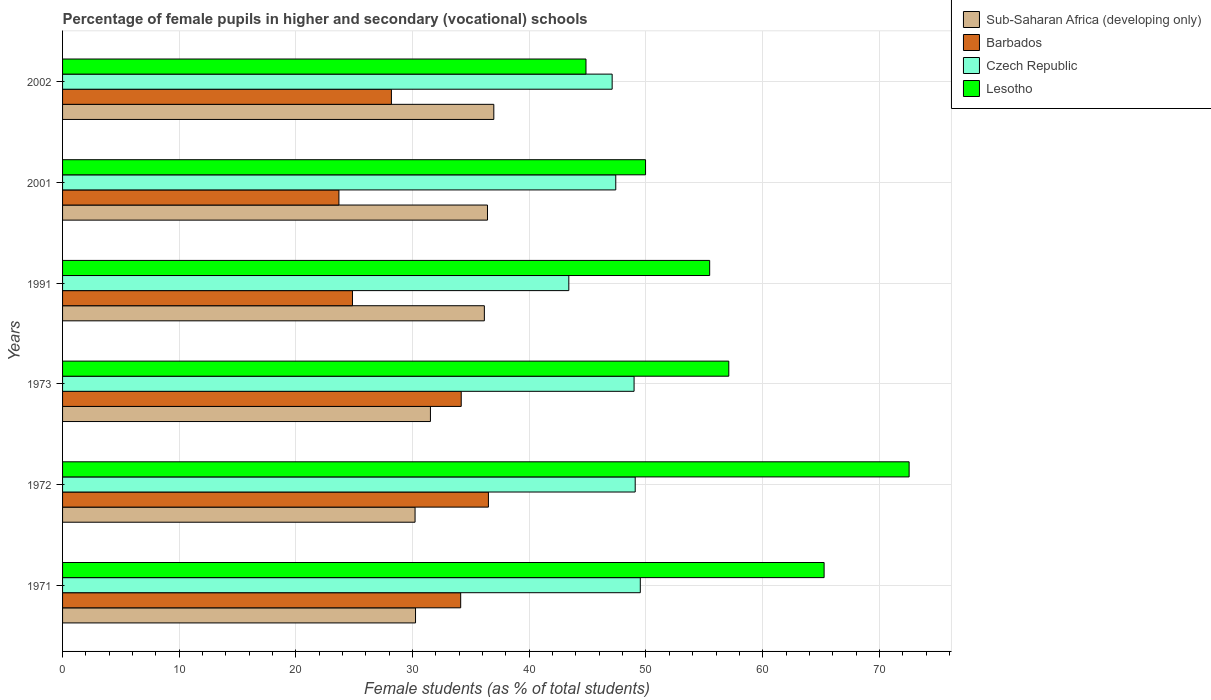How many different coloured bars are there?
Your answer should be very brief. 4. How many groups of bars are there?
Make the answer very short. 6. How many bars are there on the 2nd tick from the top?
Keep it short and to the point. 4. How many bars are there on the 6th tick from the bottom?
Ensure brevity in your answer.  4. What is the label of the 2nd group of bars from the top?
Your response must be concise. 2001. In how many cases, is the number of bars for a given year not equal to the number of legend labels?
Make the answer very short. 0. What is the percentage of female pupils in higher and secondary schools in Czech Republic in 2001?
Your answer should be compact. 47.41. Across all years, what is the maximum percentage of female pupils in higher and secondary schools in Czech Republic?
Your response must be concise. 49.51. Across all years, what is the minimum percentage of female pupils in higher and secondary schools in Czech Republic?
Make the answer very short. 43.39. In which year was the percentage of female pupils in higher and secondary schools in Sub-Saharan Africa (developing only) maximum?
Offer a terse response. 2002. In which year was the percentage of female pupils in higher and secondary schools in Sub-Saharan Africa (developing only) minimum?
Keep it short and to the point. 1972. What is the total percentage of female pupils in higher and secondary schools in Czech Republic in the graph?
Provide a succinct answer. 285.46. What is the difference between the percentage of female pupils in higher and secondary schools in Lesotho in 1991 and that in 2002?
Offer a terse response. 10.6. What is the difference between the percentage of female pupils in higher and secondary schools in Czech Republic in 2001 and the percentage of female pupils in higher and secondary schools in Lesotho in 2002?
Give a very brief answer. 2.55. What is the average percentage of female pupils in higher and secondary schools in Lesotho per year?
Provide a short and direct response. 57.53. In the year 2002, what is the difference between the percentage of female pupils in higher and secondary schools in Barbados and percentage of female pupils in higher and secondary schools in Czech Republic?
Make the answer very short. -18.92. What is the ratio of the percentage of female pupils in higher and secondary schools in Sub-Saharan Africa (developing only) in 1971 to that in 2001?
Provide a short and direct response. 0.83. Is the difference between the percentage of female pupils in higher and secondary schools in Barbados in 1973 and 2002 greater than the difference between the percentage of female pupils in higher and secondary schools in Czech Republic in 1973 and 2002?
Offer a very short reply. Yes. What is the difference between the highest and the second highest percentage of female pupils in higher and secondary schools in Czech Republic?
Give a very brief answer. 0.44. What is the difference between the highest and the lowest percentage of female pupils in higher and secondary schools in Lesotho?
Keep it short and to the point. 27.69. In how many years, is the percentage of female pupils in higher and secondary schools in Lesotho greater than the average percentage of female pupils in higher and secondary schools in Lesotho taken over all years?
Your answer should be very brief. 2. What does the 1st bar from the top in 1972 represents?
Your response must be concise. Lesotho. What does the 3rd bar from the bottom in 1972 represents?
Provide a short and direct response. Czech Republic. How many bars are there?
Provide a succinct answer. 24. What is the title of the graph?
Keep it short and to the point. Percentage of female pupils in higher and secondary (vocational) schools. Does "Andorra" appear as one of the legend labels in the graph?
Make the answer very short. No. What is the label or title of the X-axis?
Keep it short and to the point. Female students (as % of total students). What is the Female students (as % of total students) of Sub-Saharan Africa (developing only) in 1971?
Your answer should be compact. 30.25. What is the Female students (as % of total students) of Barbados in 1971?
Provide a succinct answer. 34.12. What is the Female students (as % of total students) of Czech Republic in 1971?
Your answer should be very brief. 49.51. What is the Female students (as % of total students) of Lesotho in 1971?
Make the answer very short. 65.27. What is the Female students (as % of total students) of Sub-Saharan Africa (developing only) in 1972?
Provide a short and direct response. 30.21. What is the Female students (as % of total students) of Barbados in 1972?
Keep it short and to the point. 36.5. What is the Female students (as % of total students) of Czech Republic in 1972?
Give a very brief answer. 49.08. What is the Female students (as % of total students) of Lesotho in 1972?
Keep it short and to the point. 72.55. What is the Female students (as % of total students) of Sub-Saharan Africa (developing only) in 1973?
Keep it short and to the point. 31.53. What is the Female students (as % of total students) in Barbados in 1973?
Offer a very short reply. 34.17. What is the Female students (as % of total students) of Czech Republic in 1973?
Keep it short and to the point. 48.98. What is the Female students (as % of total students) of Lesotho in 1973?
Provide a succinct answer. 57.1. What is the Female students (as % of total students) of Sub-Saharan Africa (developing only) in 1991?
Your response must be concise. 36.15. What is the Female students (as % of total students) in Barbados in 1991?
Offer a terse response. 24.84. What is the Female students (as % of total students) in Czech Republic in 1991?
Give a very brief answer. 43.39. What is the Female students (as % of total students) in Lesotho in 1991?
Provide a short and direct response. 55.46. What is the Female students (as % of total students) in Sub-Saharan Africa (developing only) in 2001?
Offer a terse response. 36.42. What is the Female students (as % of total students) of Barbados in 2001?
Offer a very short reply. 23.68. What is the Female students (as % of total students) in Czech Republic in 2001?
Give a very brief answer. 47.41. What is the Female students (as % of total students) in Lesotho in 2001?
Keep it short and to the point. 49.96. What is the Female students (as % of total students) in Sub-Saharan Africa (developing only) in 2002?
Ensure brevity in your answer.  36.96. What is the Female students (as % of total students) of Barbados in 2002?
Keep it short and to the point. 28.18. What is the Female students (as % of total students) in Czech Republic in 2002?
Keep it short and to the point. 47.1. What is the Female students (as % of total students) in Lesotho in 2002?
Make the answer very short. 44.86. Across all years, what is the maximum Female students (as % of total students) of Sub-Saharan Africa (developing only)?
Keep it short and to the point. 36.96. Across all years, what is the maximum Female students (as % of total students) of Barbados?
Your response must be concise. 36.5. Across all years, what is the maximum Female students (as % of total students) in Czech Republic?
Your answer should be compact. 49.51. Across all years, what is the maximum Female students (as % of total students) in Lesotho?
Provide a succinct answer. 72.55. Across all years, what is the minimum Female students (as % of total students) of Sub-Saharan Africa (developing only)?
Make the answer very short. 30.21. Across all years, what is the minimum Female students (as % of total students) of Barbados?
Your answer should be compact. 23.68. Across all years, what is the minimum Female students (as % of total students) of Czech Republic?
Your response must be concise. 43.39. Across all years, what is the minimum Female students (as % of total students) of Lesotho?
Offer a very short reply. 44.86. What is the total Female students (as % of total students) of Sub-Saharan Africa (developing only) in the graph?
Make the answer very short. 201.51. What is the total Female students (as % of total students) in Barbados in the graph?
Your response must be concise. 181.49. What is the total Female students (as % of total students) of Czech Republic in the graph?
Your answer should be compact. 285.46. What is the total Female students (as % of total students) in Lesotho in the graph?
Offer a very short reply. 345.19. What is the difference between the Female students (as % of total students) in Sub-Saharan Africa (developing only) in 1971 and that in 1972?
Your answer should be compact. 0.04. What is the difference between the Female students (as % of total students) of Barbados in 1971 and that in 1972?
Your response must be concise. -2.38. What is the difference between the Female students (as % of total students) of Czech Republic in 1971 and that in 1972?
Provide a succinct answer. 0.44. What is the difference between the Female students (as % of total students) of Lesotho in 1971 and that in 1972?
Provide a short and direct response. -7.29. What is the difference between the Female students (as % of total students) in Sub-Saharan Africa (developing only) in 1971 and that in 1973?
Give a very brief answer. -1.28. What is the difference between the Female students (as % of total students) in Barbados in 1971 and that in 1973?
Give a very brief answer. -0.05. What is the difference between the Female students (as % of total students) in Czech Republic in 1971 and that in 1973?
Your answer should be compact. 0.53. What is the difference between the Female students (as % of total students) in Lesotho in 1971 and that in 1973?
Make the answer very short. 8.17. What is the difference between the Female students (as % of total students) in Sub-Saharan Africa (developing only) in 1971 and that in 1991?
Keep it short and to the point. -5.9. What is the difference between the Female students (as % of total students) in Barbados in 1971 and that in 1991?
Offer a terse response. 9.27. What is the difference between the Female students (as % of total students) in Czech Republic in 1971 and that in 1991?
Offer a very short reply. 6.13. What is the difference between the Female students (as % of total students) of Lesotho in 1971 and that in 1991?
Offer a terse response. 9.81. What is the difference between the Female students (as % of total students) in Sub-Saharan Africa (developing only) in 1971 and that in 2001?
Your answer should be compact. -6.17. What is the difference between the Female students (as % of total students) in Barbados in 1971 and that in 2001?
Give a very brief answer. 10.43. What is the difference between the Female students (as % of total students) in Czech Republic in 1971 and that in 2001?
Your answer should be very brief. 2.1. What is the difference between the Female students (as % of total students) of Lesotho in 1971 and that in 2001?
Offer a terse response. 15.3. What is the difference between the Female students (as % of total students) of Sub-Saharan Africa (developing only) in 1971 and that in 2002?
Make the answer very short. -6.71. What is the difference between the Female students (as % of total students) of Barbados in 1971 and that in 2002?
Your answer should be very brief. 5.94. What is the difference between the Female students (as % of total students) in Czech Republic in 1971 and that in 2002?
Your response must be concise. 2.41. What is the difference between the Female students (as % of total students) in Lesotho in 1971 and that in 2002?
Give a very brief answer. 20.41. What is the difference between the Female students (as % of total students) of Sub-Saharan Africa (developing only) in 1972 and that in 1973?
Your answer should be very brief. -1.32. What is the difference between the Female students (as % of total students) of Barbados in 1972 and that in 1973?
Offer a very short reply. 2.33. What is the difference between the Female students (as % of total students) in Czech Republic in 1972 and that in 1973?
Give a very brief answer. 0.1. What is the difference between the Female students (as % of total students) in Lesotho in 1972 and that in 1973?
Make the answer very short. 15.45. What is the difference between the Female students (as % of total students) of Sub-Saharan Africa (developing only) in 1972 and that in 1991?
Your answer should be compact. -5.94. What is the difference between the Female students (as % of total students) of Barbados in 1972 and that in 1991?
Ensure brevity in your answer.  11.65. What is the difference between the Female students (as % of total students) in Czech Republic in 1972 and that in 1991?
Provide a short and direct response. 5.69. What is the difference between the Female students (as % of total students) of Lesotho in 1972 and that in 1991?
Keep it short and to the point. 17.09. What is the difference between the Female students (as % of total students) in Sub-Saharan Africa (developing only) in 1972 and that in 2001?
Your answer should be very brief. -6.21. What is the difference between the Female students (as % of total students) of Barbados in 1972 and that in 2001?
Your response must be concise. 12.81. What is the difference between the Female students (as % of total students) of Czech Republic in 1972 and that in 2001?
Offer a terse response. 1.67. What is the difference between the Female students (as % of total students) in Lesotho in 1972 and that in 2001?
Ensure brevity in your answer.  22.59. What is the difference between the Female students (as % of total students) in Sub-Saharan Africa (developing only) in 1972 and that in 2002?
Offer a very short reply. -6.75. What is the difference between the Female students (as % of total students) in Barbados in 1972 and that in 2002?
Offer a very short reply. 8.31. What is the difference between the Female students (as % of total students) of Czech Republic in 1972 and that in 2002?
Make the answer very short. 1.98. What is the difference between the Female students (as % of total students) in Lesotho in 1972 and that in 2002?
Offer a terse response. 27.69. What is the difference between the Female students (as % of total students) in Sub-Saharan Africa (developing only) in 1973 and that in 1991?
Provide a short and direct response. -4.62. What is the difference between the Female students (as % of total students) of Barbados in 1973 and that in 1991?
Offer a terse response. 9.32. What is the difference between the Female students (as % of total students) of Czech Republic in 1973 and that in 1991?
Give a very brief answer. 5.59. What is the difference between the Female students (as % of total students) of Lesotho in 1973 and that in 1991?
Keep it short and to the point. 1.64. What is the difference between the Female students (as % of total students) in Sub-Saharan Africa (developing only) in 1973 and that in 2001?
Your response must be concise. -4.89. What is the difference between the Female students (as % of total students) in Barbados in 1973 and that in 2001?
Offer a terse response. 10.48. What is the difference between the Female students (as % of total students) of Czech Republic in 1973 and that in 2001?
Provide a succinct answer. 1.57. What is the difference between the Female students (as % of total students) in Lesotho in 1973 and that in 2001?
Give a very brief answer. 7.13. What is the difference between the Female students (as % of total students) of Sub-Saharan Africa (developing only) in 1973 and that in 2002?
Your response must be concise. -5.43. What is the difference between the Female students (as % of total students) in Barbados in 1973 and that in 2002?
Your answer should be compact. 5.98. What is the difference between the Female students (as % of total students) of Czech Republic in 1973 and that in 2002?
Offer a very short reply. 1.88. What is the difference between the Female students (as % of total students) of Lesotho in 1973 and that in 2002?
Your answer should be compact. 12.24. What is the difference between the Female students (as % of total students) of Sub-Saharan Africa (developing only) in 1991 and that in 2001?
Make the answer very short. -0.27. What is the difference between the Female students (as % of total students) in Barbados in 1991 and that in 2001?
Your response must be concise. 1.16. What is the difference between the Female students (as % of total students) in Czech Republic in 1991 and that in 2001?
Ensure brevity in your answer.  -4.02. What is the difference between the Female students (as % of total students) of Lesotho in 1991 and that in 2001?
Make the answer very short. 5.5. What is the difference between the Female students (as % of total students) in Sub-Saharan Africa (developing only) in 1991 and that in 2002?
Your answer should be very brief. -0.81. What is the difference between the Female students (as % of total students) in Barbados in 1991 and that in 2002?
Give a very brief answer. -3.34. What is the difference between the Female students (as % of total students) of Czech Republic in 1991 and that in 2002?
Your answer should be very brief. -3.71. What is the difference between the Female students (as % of total students) of Lesotho in 1991 and that in 2002?
Make the answer very short. 10.6. What is the difference between the Female students (as % of total students) in Sub-Saharan Africa (developing only) in 2001 and that in 2002?
Ensure brevity in your answer.  -0.54. What is the difference between the Female students (as % of total students) of Barbados in 2001 and that in 2002?
Offer a very short reply. -4.5. What is the difference between the Female students (as % of total students) of Czech Republic in 2001 and that in 2002?
Keep it short and to the point. 0.31. What is the difference between the Female students (as % of total students) in Lesotho in 2001 and that in 2002?
Keep it short and to the point. 5.1. What is the difference between the Female students (as % of total students) of Sub-Saharan Africa (developing only) in 1971 and the Female students (as % of total students) of Barbados in 1972?
Make the answer very short. -6.25. What is the difference between the Female students (as % of total students) of Sub-Saharan Africa (developing only) in 1971 and the Female students (as % of total students) of Czech Republic in 1972?
Provide a succinct answer. -18.83. What is the difference between the Female students (as % of total students) of Sub-Saharan Africa (developing only) in 1971 and the Female students (as % of total students) of Lesotho in 1972?
Ensure brevity in your answer.  -42.3. What is the difference between the Female students (as % of total students) of Barbados in 1971 and the Female students (as % of total students) of Czech Republic in 1972?
Provide a short and direct response. -14.96. What is the difference between the Female students (as % of total students) of Barbados in 1971 and the Female students (as % of total students) of Lesotho in 1972?
Keep it short and to the point. -38.43. What is the difference between the Female students (as % of total students) of Czech Republic in 1971 and the Female students (as % of total students) of Lesotho in 1972?
Give a very brief answer. -23.04. What is the difference between the Female students (as % of total students) of Sub-Saharan Africa (developing only) in 1971 and the Female students (as % of total students) of Barbados in 1973?
Your answer should be very brief. -3.92. What is the difference between the Female students (as % of total students) in Sub-Saharan Africa (developing only) in 1971 and the Female students (as % of total students) in Czech Republic in 1973?
Provide a succinct answer. -18.73. What is the difference between the Female students (as % of total students) in Sub-Saharan Africa (developing only) in 1971 and the Female students (as % of total students) in Lesotho in 1973?
Give a very brief answer. -26.85. What is the difference between the Female students (as % of total students) of Barbados in 1971 and the Female students (as % of total students) of Czech Republic in 1973?
Your answer should be compact. -14.86. What is the difference between the Female students (as % of total students) of Barbados in 1971 and the Female students (as % of total students) of Lesotho in 1973?
Offer a very short reply. -22.98. What is the difference between the Female students (as % of total students) in Czech Republic in 1971 and the Female students (as % of total students) in Lesotho in 1973?
Offer a terse response. -7.58. What is the difference between the Female students (as % of total students) of Sub-Saharan Africa (developing only) in 1971 and the Female students (as % of total students) of Barbados in 1991?
Offer a very short reply. 5.4. What is the difference between the Female students (as % of total students) in Sub-Saharan Africa (developing only) in 1971 and the Female students (as % of total students) in Czech Republic in 1991?
Give a very brief answer. -13.14. What is the difference between the Female students (as % of total students) of Sub-Saharan Africa (developing only) in 1971 and the Female students (as % of total students) of Lesotho in 1991?
Offer a terse response. -25.21. What is the difference between the Female students (as % of total students) of Barbados in 1971 and the Female students (as % of total students) of Czech Republic in 1991?
Provide a short and direct response. -9.27. What is the difference between the Female students (as % of total students) in Barbados in 1971 and the Female students (as % of total students) in Lesotho in 1991?
Provide a short and direct response. -21.34. What is the difference between the Female students (as % of total students) in Czech Republic in 1971 and the Female students (as % of total students) in Lesotho in 1991?
Provide a short and direct response. -5.95. What is the difference between the Female students (as % of total students) of Sub-Saharan Africa (developing only) in 1971 and the Female students (as % of total students) of Barbados in 2001?
Provide a succinct answer. 6.57. What is the difference between the Female students (as % of total students) in Sub-Saharan Africa (developing only) in 1971 and the Female students (as % of total students) in Czech Republic in 2001?
Your answer should be very brief. -17.16. What is the difference between the Female students (as % of total students) in Sub-Saharan Africa (developing only) in 1971 and the Female students (as % of total students) in Lesotho in 2001?
Keep it short and to the point. -19.71. What is the difference between the Female students (as % of total students) of Barbados in 1971 and the Female students (as % of total students) of Czech Republic in 2001?
Your answer should be compact. -13.29. What is the difference between the Female students (as % of total students) of Barbados in 1971 and the Female students (as % of total students) of Lesotho in 2001?
Make the answer very short. -15.84. What is the difference between the Female students (as % of total students) of Czech Republic in 1971 and the Female students (as % of total students) of Lesotho in 2001?
Provide a succinct answer. -0.45. What is the difference between the Female students (as % of total students) in Sub-Saharan Africa (developing only) in 1971 and the Female students (as % of total students) in Barbados in 2002?
Provide a short and direct response. 2.07. What is the difference between the Female students (as % of total students) in Sub-Saharan Africa (developing only) in 1971 and the Female students (as % of total students) in Czech Republic in 2002?
Offer a very short reply. -16.85. What is the difference between the Female students (as % of total students) in Sub-Saharan Africa (developing only) in 1971 and the Female students (as % of total students) in Lesotho in 2002?
Offer a very short reply. -14.61. What is the difference between the Female students (as % of total students) of Barbados in 1971 and the Female students (as % of total students) of Czech Republic in 2002?
Offer a terse response. -12.98. What is the difference between the Female students (as % of total students) in Barbados in 1971 and the Female students (as % of total students) in Lesotho in 2002?
Give a very brief answer. -10.74. What is the difference between the Female students (as % of total students) of Czech Republic in 1971 and the Female students (as % of total students) of Lesotho in 2002?
Offer a very short reply. 4.65. What is the difference between the Female students (as % of total students) of Sub-Saharan Africa (developing only) in 1972 and the Female students (as % of total students) of Barbados in 1973?
Provide a succinct answer. -3.96. What is the difference between the Female students (as % of total students) in Sub-Saharan Africa (developing only) in 1972 and the Female students (as % of total students) in Czech Republic in 1973?
Your answer should be very brief. -18.77. What is the difference between the Female students (as % of total students) of Sub-Saharan Africa (developing only) in 1972 and the Female students (as % of total students) of Lesotho in 1973?
Your response must be concise. -26.89. What is the difference between the Female students (as % of total students) in Barbados in 1972 and the Female students (as % of total students) in Czech Republic in 1973?
Your answer should be compact. -12.48. What is the difference between the Female students (as % of total students) of Barbados in 1972 and the Female students (as % of total students) of Lesotho in 1973?
Offer a very short reply. -20.6. What is the difference between the Female students (as % of total students) of Czech Republic in 1972 and the Female students (as % of total students) of Lesotho in 1973?
Offer a terse response. -8.02. What is the difference between the Female students (as % of total students) in Sub-Saharan Africa (developing only) in 1972 and the Female students (as % of total students) in Barbados in 1991?
Make the answer very short. 5.36. What is the difference between the Female students (as % of total students) of Sub-Saharan Africa (developing only) in 1972 and the Female students (as % of total students) of Czech Republic in 1991?
Offer a very short reply. -13.18. What is the difference between the Female students (as % of total students) in Sub-Saharan Africa (developing only) in 1972 and the Female students (as % of total students) in Lesotho in 1991?
Provide a short and direct response. -25.25. What is the difference between the Female students (as % of total students) of Barbados in 1972 and the Female students (as % of total students) of Czech Republic in 1991?
Keep it short and to the point. -6.89. What is the difference between the Female students (as % of total students) of Barbados in 1972 and the Female students (as % of total students) of Lesotho in 1991?
Give a very brief answer. -18.96. What is the difference between the Female students (as % of total students) of Czech Republic in 1972 and the Female students (as % of total students) of Lesotho in 1991?
Give a very brief answer. -6.38. What is the difference between the Female students (as % of total students) of Sub-Saharan Africa (developing only) in 1972 and the Female students (as % of total students) of Barbados in 2001?
Make the answer very short. 6.52. What is the difference between the Female students (as % of total students) in Sub-Saharan Africa (developing only) in 1972 and the Female students (as % of total students) in Czech Republic in 2001?
Ensure brevity in your answer.  -17.2. What is the difference between the Female students (as % of total students) in Sub-Saharan Africa (developing only) in 1972 and the Female students (as % of total students) in Lesotho in 2001?
Offer a terse response. -19.75. What is the difference between the Female students (as % of total students) in Barbados in 1972 and the Female students (as % of total students) in Czech Republic in 2001?
Offer a terse response. -10.91. What is the difference between the Female students (as % of total students) in Barbados in 1972 and the Female students (as % of total students) in Lesotho in 2001?
Ensure brevity in your answer.  -13.47. What is the difference between the Female students (as % of total students) of Czech Republic in 1972 and the Female students (as % of total students) of Lesotho in 2001?
Offer a terse response. -0.89. What is the difference between the Female students (as % of total students) of Sub-Saharan Africa (developing only) in 1972 and the Female students (as % of total students) of Barbados in 2002?
Your answer should be very brief. 2.03. What is the difference between the Female students (as % of total students) of Sub-Saharan Africa (developing only) in 1972 and the Female students (as % of total students) of Czech Republic in 2002?
Make the answer very short. -16.89. What is the difference between the Female students (as % of total students) in Sub-Saharan Africa (developing only) in 1972 and the Female students (as % of total students) in Lesotho in 2002?
Your answer should be compact. -14.65. What is the difference between the Female students (as % of total students) in Barbados in 1972 and the Female students (as % of total students) in Czech Republic in 2002?
Offer a terse response. -10.6. What is the difference between the Female students (as % of total students) of Barbados in 1972 and the Female students (as % of total students) of Lesotho in 2002?
Keep it short and to the point. -8.36. What is the difference between the Female students (as % of total students) of Czech Republic in 1972 and the Female students (as % of total students) of Lesotho in 2002?
Provide a succinct answer. 4.22. What is the difference between the Female students (as % of total students) of Sub-Saharan Africa (developing only) in 1973 and the Female students (as % of total students) of Barbados in 1991?
Ensure brevity in your answer.  6.68. What is the difference between the Female students (as % of total students) of Sub-Saharan Africa (developing only) in 1973 and the Female students (as % of total students) of Czech Republic in 1991?
Make the answer very short. -11.86. What is the difference between the Female students (as % of total students) in Sub-Saharan Africa (developing only) in 1973 and the Female students (as % of total students) in Lesotho in 1991?
Provide a succinct answer. -23.93. What is the difference between the Female students (as % of total students) in Barbados in 1973 and the Female students (as % of total students) in Czech Republic in 1991?
Make the answer very short. -9.22. What is the difference between the Female students (as % of total students) of Barbados in 1973 and the Female students (as % of total students) of Lesotho in 1991?
Your answer should be compact. -21.29. What is the difference between the Female students (as % of total students) of Czech Republic in 1973 and the Female students (as % of total students) of Lesotho in 1991?
Offer a terse response. -6.48. What is the difference between the Female students (as % of total students) of Sub-Saharan Africa (developing only) in 1973 and the Female students (as % of total students) of Barbados in 2001?
Keep it short and to the point. 7.84. What is the difference between the Female students (as % of total students) in Sub-Saharan Africa (developing only) in 1973 and the Female students (as % of total students) in Czech Republic in 2001?
Your answer should be very brief. -15.88. What is the difference between the Female students (as % of total students) in Sub-Saharan Africa (developing only) in 1973 and the Female students (as % of total students) in Lesotho in 2001?
Keep it short and to the point. -18.44. What is the difference between the Female students (as % of total students) of Barbados in 1973 and the Female students (as % of total students) of Czech Republic in 2001?
Make the answer very short. -13.24. What is the difference between the Female students (as % of total students) of Barbados in 1973 and the Female students (as % of total students) of Lesotho in 2001?
Your answer should be compact. -15.8. What is the difference between the Female students (as % of total students) in Czech Republic in 1973 and the Female students (as % of total students) in Lesotho in 2001?
Ensure brevity in your answer.  -0.98. What is the difference between the Female students (as % of total students) of Sub-Saharan Africa (developing only) in 1973 and the Female students (as % of total students) of Barbados in 2002?
Make the answer very short. 3.35. What is the difference between the Female students (as % of total students) of Sub-Saharan Africa (developing only) in 1973 and the Female students (as % of total students) of Czech Republic in 2002?
Provide a succinct answer. -15.57. What is the difference between the Female students (as % of total students) in Sub-Saharan Africa (developing only) in 1973 and the Female students (as % of total students) in Lesotho in 2002?
Offer a terse response. -13.33. What is the difference between the Female students (as % of total students) of Barbados in 1973 and the Female students (as % of total students) of Czech Republic in 2002?
Offer a terse response. -12.93. What is the difference between the Female students (as % of total students) of Barbados in 1973 and the Female students (as % of total students) of Lesotho in 2002?
Give a very brief answer. -10.69. What is the difference between the Female students (as % of total students) of Czech Republic in 1973 and the Female students (as % of total students) of Lesotho in 2002?
Your answer should be very brief. 4.12. What is the difference between the Female students (as % of total students) of Sub-Saharan Africa (developing only) in 1991 and the Female students (as % of total students) of Barbados in 2001?
Your answer should be compact. 12.46. What is the difference between the Female students (as % of total students) in Sub-Saharan Africa (developing only) in 1991 and the Female students (as % of total students) in Czech Republic in 2001?
Provide a succinct answer. -11.26. What is the difference between the Female students (as % of total students) of Sub-Saharan Africa (developing only) in 1991 and the Female students (as % of total students) of Lesotho in 2001?
Offer a terse response. -13.81. What is the difference between the Female students (as % of total students) of Barbados in 1991 and the Female students (as % of total students) of Czech Republic in 2001?
Ensure brevity in your answer.  -22.57. What is the difference between the Female students (as % of total students) in Barbados in 1991 and the Female students (as % of total students) in Lesotho in 2001?
Your answer should be very brief. -25.12. What is the difference between the Female students (as % of total students) of Czech Republic in 1991 and the Female students (as % of total students) of Lesotho in 2001?
Give a very brief answer. -6.58. What is the difference between the Female students (as % of total students) in Sub-Saharan Africa (developing only) in 1991 and the Female students (as % of total students) in Barbados in 2002?
Ensure brevity in your answer.  7.97. What is the difference between the Female students (as % of total students) in Sub-Saharan Africa (developing only) in 1991 and the Female students (as % of total students) in Czech Republic in 2002?
Provide a succinct answer. -10.95. What is the difference between the Female students (as % of total students) in Sub-Saharan Africa (developing only) in 1991 and the Female students (as % of total students) in Lesotho in 2002?
Offer a terse response. -8.71. What is the difference between the Female students (as % of total students) of Barbados in 1991 and the Female students (as % of total students) of Czech Republic in 2002?
Offer a very short reply. -22.26. What is the difference between the Female students (as % of total students) in Barbados in 1991 and the Female students (as % of total students) in Lesotho in 2002?
Provide a short and direct response. -20.01. What is the difference between the Female students (as % of total students) of Czech Republic in 1991 and the Female students (as % of total students) of Lesotho in 2002?
Your answer should be compact. -1.47. What is the difference between the Female students (as % of total students) of Sub-Saharan Africa (developing only) in 2001 and the Female students (as % of total students) of Barbados in 2002?
Offer a terse response. 8.23. What is the difference between the Female students (as % of total students) in Sub-Saharan Africa (developing only) in 2001 and the Female students (as % of total students) in Czech Republic in 2002?
Make the answer very short. -10.68. What is the difference between the Female students (as % of total students) in Sub-Saharan Africa (developing only) in 2001 and the Female students (as % of total students) in Lesotho in 2002?
Give a very brief answer. -8.44. What is the difference between the Female students (as % of total students) of Barbados in 2001 and the Female students (as % of total students) of Czech Republic in 2002?
Your answer should be compact. -23.42. What is the difference between the Female students (as % of total students) of Barbados in 2001 and the Female students (as % of total students) of Lesotho in 2002?
Provide a short and direct response. -21.17. What is the difference between the Female students (as % of total students) in Czech Republic in 2001 and the Female students (as % of total students) in Lesotho in 2002?
Your response must be concise. 2.55. What is the average Female students (as % of total students) of Sub-Saharan Africa (developing only) per year?
Your answer should be very brief. 33.58. What is the average Female students (as % of total students) of Barbados per year?
Provide a succinct answer. 30.25. What is the average Female students (as % of total students) in Czech Republic per year?
Provide a succinct answer. 47.58. What is the average Female students (as % of total students) in Lesotho per year?
Your answer should be very brief. 57.53. In the year 1971, what is the difference between the Female students (as % of total students) of Sub-Saharan Africa (developing only) and Female students (as % of total students) of Barbados?
Keep it short and to the point. -3.87. In the year 1971, what is the difference between the Female students (as % of total students) of Sub-Saharan Africa (developing only) and Female students (as % of total students) of Czech Republic?
Offer a terse response. -19.26. In the year 1971, what is the difference between the Female students (as % of total students) in Sub-Saharan Africa (developing only) and Female students (as % of total students) in Lesotho?
Provide a succinct answer. -35.02. In the year 1971, what is the difference between the Female students (as % of total students) of Barbados and Female students (as % of total students) of Czech Republic?
Provide a succinct answer. -15.39. In the year 1971, what is the difference between the Female students (as % of total students) in Barbados and Female students (as % of total students) in Lesotho?
Provide a short and direct response. -31.15. In the year 1971, what is the difference between the Female students (as % of total students) of Czech Republic and Female students (as % of total students) of Lesotho?
Offer a very short reply. -15.75. In the year 1972, what is the difference between the Female students (as % of total students) of Sub-Saharan Africa (developing only) and Female students (as % of total students) of Barbados?
Provide a succinct answer. -6.29. In the year 1972, what is the difference between the Female students (as % of total students) of Sub-Saharan Africa (developing only) and Female students (as % of total students) of Czech Republic?
Provide a short and direct response. -18.87. In the year 1972, what is the difference between the Female students (as % of total students) in Sub-Saharan Africa (developing only) and Female students (as % of total students) in Lesotho?
Keep it short and to the point. -42.34. In the year 1972, what is the difference between the Female students (as % of total students) of Barbados and Female students (as % of total students) of Czech Republic?
Ensure brevity in your answer.  -12.58. In the year 1972, what is the difference between the Female students (as % of total students) in Barbados and Female students (as % of total students) in Lesotho?
Make the answer very short. -36.05. In the year 1972, what is the difference between the Female students (as % of total students) in Czech Republic and Female students (as % of total students) in Lesotho?
Offer a terse response. -23.48. In the year 1973, what is the difference between the Female students (as % of total students) in Sub-Saharan Africa (developing only) and Female students (as % of total students) in Barbados?
Offer a terse response. -2.64. In the year 1973, what is the difference between the Female students (as % of total students) in Sub-Saharan Africa (developing only) and Female students (as % of total students) in Czech Republic?
Provide a short and direct response. -17.45. In the year 1973, what is the difference between the Female students (as % of total students) of Sub-Saharan Africa (developing only) and Female students (as % of total students) of Lesotho?
Give a very brief answer. -25.57. In the year 1973, what is the difference between the Female students (as % of total students) of Barbados and Female students (as % of total students) of Czech Republic?
Provide a short and direct response. -14.81. In the year 1973, what is the difference between the Female students (as % of total students) of Barbados and Female students (as % of total students) of Lesotho?
Provide a short and direct response. -22.93. In the year 1973, what is the difference between the Female students (as % of total students) of Czech Republic and Female students (as % of total students) of Lesotho?
Your answer should be very brief. -8.12. In the year 1991, what is the difference between the Female students (as % of total students) in Sub-Saharan Africa (developing only) and Female students (as % of total students) in Barbados?
Make the answer very short. 11.3. In the year 1991, what is the difference between the Female students (as % of total students) in Sub-Saharan Africa (developing only) and Female students (as % of total students) in Czech Republic?
Give a very brief answer. -7.24. In the year 1991, what is the difference between the Female students (as % of total students) in Sub-Saharan Africa (developing only) and Female students (as % of total students) in Lesotho?
Ensure brevity in your answer.  -19.31. In the year 1991, what is the difference between the Female students (as % of total students) of Barbados and Female students (as % of total students) of Czech Republic?
Give a very brief answer. -18.54. In the year 1991, what is the difference between the Female students (as % of total students) of Barbados and Female students (as % of total students) of Lesotho?
Give a very brief answer. -30.61. In the year 1991, what is the difference between the Female students (as % of total students) of Czech Republic and Female students (as % of total students) of Lesotho?
Offer a terse response. -12.07. In the year 2001, what is the difference between the Female students (as % of total students) of Sub-Saharan Africa (developing only) and Female students (as % of total students) of Barbados?
Make the answer very short. 12.73. In the year 2001, what is the difference between the Female students (as % of total students) of Sub-Saharan Africa (developing only) and Female students (as % of total students) of Czech Republic?
Offer a very short reply. -10.99. In the year 2001, what is the difference between the Female students (as % of total students) in Sub-Saharan Africa (developing only) and Female students (as % of total students) in Lesotho?
Give a very brief answer. -13.55. In the year 2001, what is the difference between the Female students (as % of total students) in Barbados and Female students (as % of total students) in Czech Republic?
Your response must be concise. -23.73. In the year 2001, what is the difference between the Female students (as % of total students) in Barbados and Female students (as % of total students) in Lesotho?
Keep it short and to the point. -26.28. In the year 2001, what is the difference between the Female students (as % of total students) in Czech Republic and Female students (as % of total students) in Lesotho?
Offer a terse response. -2.55. In the year 2002, what is the difference between the Female students (as % of total students) of Sub-Saharan Africa (developing only) and Female students (as % of total students) of Barbados?
Ensure brevity in your answer.  8.78. In the year 2002, what is the difference between the Female students (as % of total students) of Sub-Saharan Africa (developing only) and Female students (as % of total students) of Czech Republic?
Provide a short and direct response. -10.14. In the year 2002, what is the difference between the Female students (as % of total students) in Sub-Saharan Africa (developing only) and Female students (as % of total students) in Lesotho?
Your response must be concise. -7.9. In the year 2002, what is the difference between the Female students (as % of total students) of Barbados and Female students (as % of total students) of Czech Republic?
Offer a very short reply. -18.92. In the year 2002, what is the difference between the Female students (as % of total students) of Barbados and Female students (as % of total students) of Lesotho?
Your answer should be very brief. -16.68. In the year 2002, what is the difference between the Female students (as % of total students) in Czech Republic and Female students (as % of total students) in Lesotho?
Give a very brief answer. 2.24. What is the ratio of the Female students (as % of total students) in Barbados in 1971 to that in 1972?
Offer a very short reply. 0.93. What is the ratio of the Female students (as % of total students) in Czech Republic in 1971 to that in 1972?
Your answer should be very brief. 1.01. What is the ratio of the Female students (as % of total students) in Lesotho in 1971 to that in 1972?
Your response must be concise. 0.9. What is the ratio of the Female students (as % of total students) of Sub-Saharan Africa (developing only) in 1971 to that in 1973?
Offer a terse response. 0.96. What is the ratio of the Female students (as % of total students) of Barbados in 1971 to that in 1973?
Your response must be concise. 1. What is the ratio of the Female students (as % of total students) of Czech Republic in 1971 to that in 1973?
Your answer should be compact. 1.01. What is the ratio of the Female students (as % of total students) of Lesotho in 1971 to that in 1973?
Keep it short and to the point. 1.14. What is the ratio of the Female students (as % of total students) in Sub-Saharan Africa (developing only) in 1971 to that in 1991?
Your answer should be very brief. 0.84. What is the ratio of the Female students (as % of total students) in Barbados in 1971 to that in 1991?
Your answer should be compact. 1.37. What is the ratio of the Female students (as % of total students) in Czech Republic in 1971 to that in 1991?
Ensure brevity in your answer.  1.14. What is the ratio of the Female students (as % of total students) of Lesotho in 1971 to that in 1991?
Your response must be concise. 1.18. What is the ratio of the Female students (as % of total students) of Sub-Saharan Africa (developing only) in 1971 to that in 2001?
Your answer should be compact. 0.83. What is the ratio of the Female students (as % of total students) in Barbados in 1971 to that in 2001?
Make the answer very short. 1.44. What is the ratio of the Female students (as % of total students) in Czech Republic in 1971 to that in 2001?
Your answer should be compact. 1.04. What is the ratio of the Female students (as % of total students) in Lesotho in 1971 to that in 2001?
Your response must be concise. 1.31. What is the ratio of the Female students (as % of total students) of Sub-Saharan Africa (developing only) in 1971 to that in 2002?
Your answer should be very brief. 0.82. What is the ratio of the Female students (as % of total students) in Barbados in 1971 to that in 2002?
Your response must be concise. 1.21. What is the ratio of the Female students (as % of total students) of Czech Republic in 1971 to that in 2002?
Offer a terse response. 1.05. What is the ratio of the Female students (as % of total students) in Lesotho in 1971 to that in 2002?
Your response must be concise. 1.45. What is the ratio of the Female students (as % of total students) of Sub-Saharan Africa (developing only) in 1972 to that in 1973?
Give a very brief answer. 0.96. What is the ratio of the Female students (as % of total students) of Barbados in 1972 to that in 1973?
Provide a succinct answer. 1.07. What is the ratio of the Female students (as % of total students) in Lesotho in 1972 to that in 1973?
Provide a short and direct response. 1.27. What is the ratio of the Female students (as % of total students) of Sub-Saharan Africa (developing only) in 1972 to that in 1991?
Keep it short and to the point. 0.84. What is the ratio of the Female students (as % of total students) in Barbados in 1972 to that in 1991?
Make the answer very short. 1.47. What is the ratio of the Female students (as % of total students) of Czech Republic in 1972 to that in 1991?
Provide a short and direct response. 1.13. What is the ratio of the Female students (as % of total students) of Lesotho in 1972 to that in 1991?
Your answer should be very brief. 1.31. What is the ratio of the Female students (as % of total students) in Sub-Saharan Africa (developing only) in 1972 to that in 2001?
Provide a short and direct response. 0.83. What is the ratio of the Female students (as % of total students) in Barbados in 1972 to that in 2001?
Give a very brief answer. 1.54. What is the ratio of the Female students (as % of total students) in Czech Republic in 1972 to that in 2001?
Give a very brief answer. 1.04. What is the ratio of the Female students (as % of total students) of Lesotho in 1972 to that in 2001?
Your response must be concise. 1.45. What is the ratio of the Female students (as % of total students) of Sub-Saharan Africa (developing only) in 1972 to that in 2002?
Ensure brevity in your answer.  0.82. What is the ratio of the Female students (as % of total students) in Barbados in 1972 to that in 2002?
Offer a terse response. 1.29. What is the ratio of the Female students (as % of total students) in Czech Republic in 1972 to that in 2002?
Make the answer very short. 1.04. What is the ratio of the Female students (as % of total students) of Lesotho in 1972 to that in 2002?
Give a very brief answer. 1.62. What is the ratio of the Female students (as % of total students) of Sub-Saharan Africa (developing only) in 1973 to that in 1991?
Keep it short and to the point. 0.87. What is the ratio of the Female students (as % of total students) in Barbados in 1973 to that in 1991?
Ensure brevity in your answer.  1.38. What is the ratio of the Female students (as % of total students) in Czech Republic in 1973 to that in 1991?
Keep it short and to the point. 1.13. What is the ratio of the Female students (as % of total students) in Lesotho in 1973 to that in 1991?
Offer a terse response. 1.03. What is the ratio of the Female students (as % of total students) in Sub-Saharan Africa (developing only) in 1973 to that in 2001?
Your answer should be compact. 0.87. What is the ratio of the Female students (as % of total students) in Barbados in 1973 to that in 2001?
Offer a very short reply. 1.44. What is the ratio of the Female students (as % of total students) of Czech Republic in 1973 to that in 2001?
Ensure brevity in your answer.  1.03. What is the ratio of the Female students (as % of total students) in Lesotho in 1973 to that in 2001?
Make the answer very short. 1.14. What is the ratio of the Female students (as % of total students) in Sub-Saharan Africa (developing only) in 1973 to that in 2002?
Offer a terse response. 0.85. What is the ratio of the Female students (as % of total students) of Barbados in 1973 to that in 2002?
Offer a very short reply. 1.21. What is the ratio of the Female students (as % of total students) in Czech Republic in 1973 to that in 2002?
Your response must be concise. 1.04. What is the ratio of the Female students (as % of total students) of Lesotho in 1973 to that in 2002?
Keep it short and to the point. 1.27. What is the ratio of the Female students (as % of total students) of Barbados in 1991 to that in 2001?
Your answer should be very brief. 1.05. What is the ratio of the Female students (as % of total students) of Czech Republic in 1991 to that in 2001?
Your answer should be compact. 0.92. What is the ratio of the Female students (as % of total students) of Lesotho in 1991 to that in 2001?
Provide a short and direct response. 1.11. What is the ratio of the Female students (as % of total students) in Sub-Saharan Africa (developing only) in 1991 to that in 2002?
Provide a succinct answer. 0.98. What is the ratio of the Female students (as % of total students) in Barbados in 1991 to that in 2002?
Make the answer very short. 0.88. What is the ratio of the Female students (as % of total students) in Czech Republic in 1991 to that in 2002?
Provide a short and direct response. 0.92. What is the ratio of the Female students (as % of total students) in Lesotho in 1991 to that in 2002?
Keep it short and to the point. 1.24. What is the ratio of the Female students (as % of total students) in Barbados in 2001 to that in 2002?
Provide a succinct answer. 0.84. What is the ratio of the Female students (as % of total students) in Czech Republic in 2001 to that in 2002?
Make the answer very short. 1.01. What is the ratio of the Female students (as % of total students) in Lesotho in 2001 to that in 2002?
Your answer should be very brief. 1.11. What is the difference between the highest and the second highest Female students (as % of total students) of Sub-Saharan Africa (developing only)?
Offer a terse response. 0.54. What is the difference between the highest and the second highest Female students (as % of total students) of Barbados?
Provide a short and direct response. 2.33. What is the difference between the highest and the second highest Female students (as % of total students) of Czech Republic?
Keep it short and to the point. 0.44. What is the difference between the highest and the second highest Female students (as % of total students) of Lesotho?
Offer a terse response. 7.29. What is the difference between the highest and the lowest Female students (as % of total students) in Sub-Saharan Africa (developing only)?
Keep it short and to the point. 6.75. What is the difference between the highest and the lowest Female students (as % of total students) of Barbados?
Make the answer very short. 12.81. What is the difference between the highest and the lowest Female students (as % of total students) of Czech Republic?
Ensure brevity in your answer.  6.13. What is the difference between the highest and the lowest Female students (as % of total students) of Lesotho?
Offer a very short reply. 27.69. 